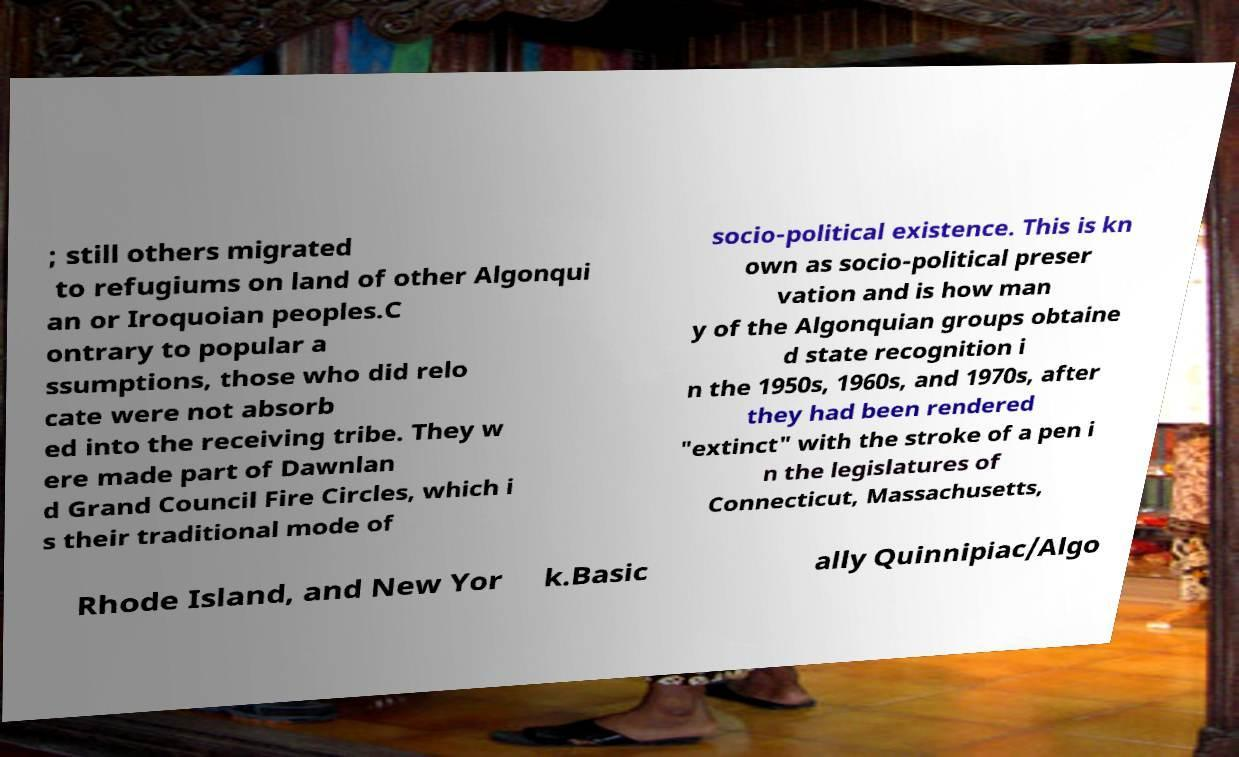Could you extract and type out the text from this image? ; still others migrated to refugiums on land of other Algonqui an or Iroquoian peoples.C ontrary to popular a ssumptions, those who did relo cate were not absorb ed into the receiving tribe. They w ere made part of Dawnlan d Grand Council Fire Circles, which i s their traditional mode of socio-political existence. This is kn own as socio-political preser vation and is how man y of the Algonquian groups obtaine d state recognition i n the 1950s, 1960s, and 1970s, after they had been rendered "extinct" with the stroke of a pen i n the legislatures of Connecticut, Massachusetts, Rhode Island, and New Yor k.Basic ally Quinnipiac/Algo 